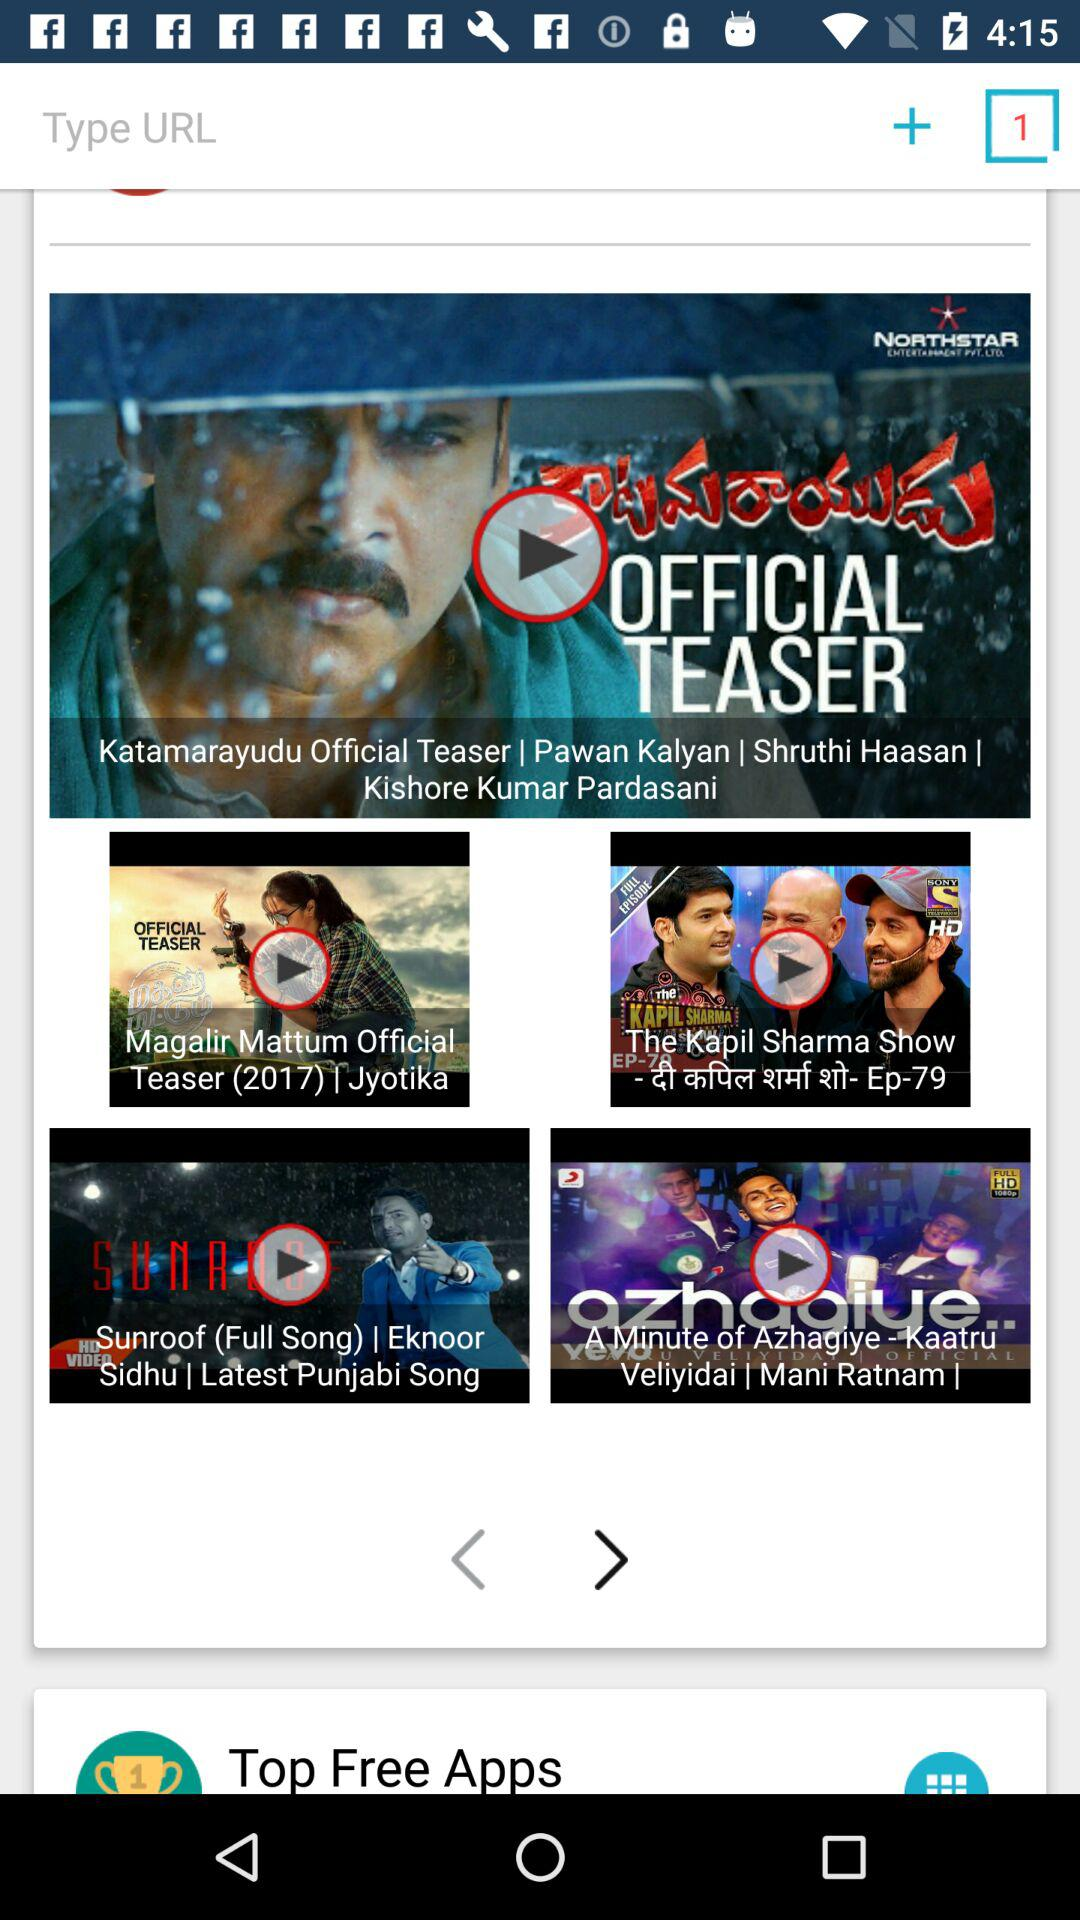Who is the singer of "Sunroof"? The singer is Eknoor Sidhu. 